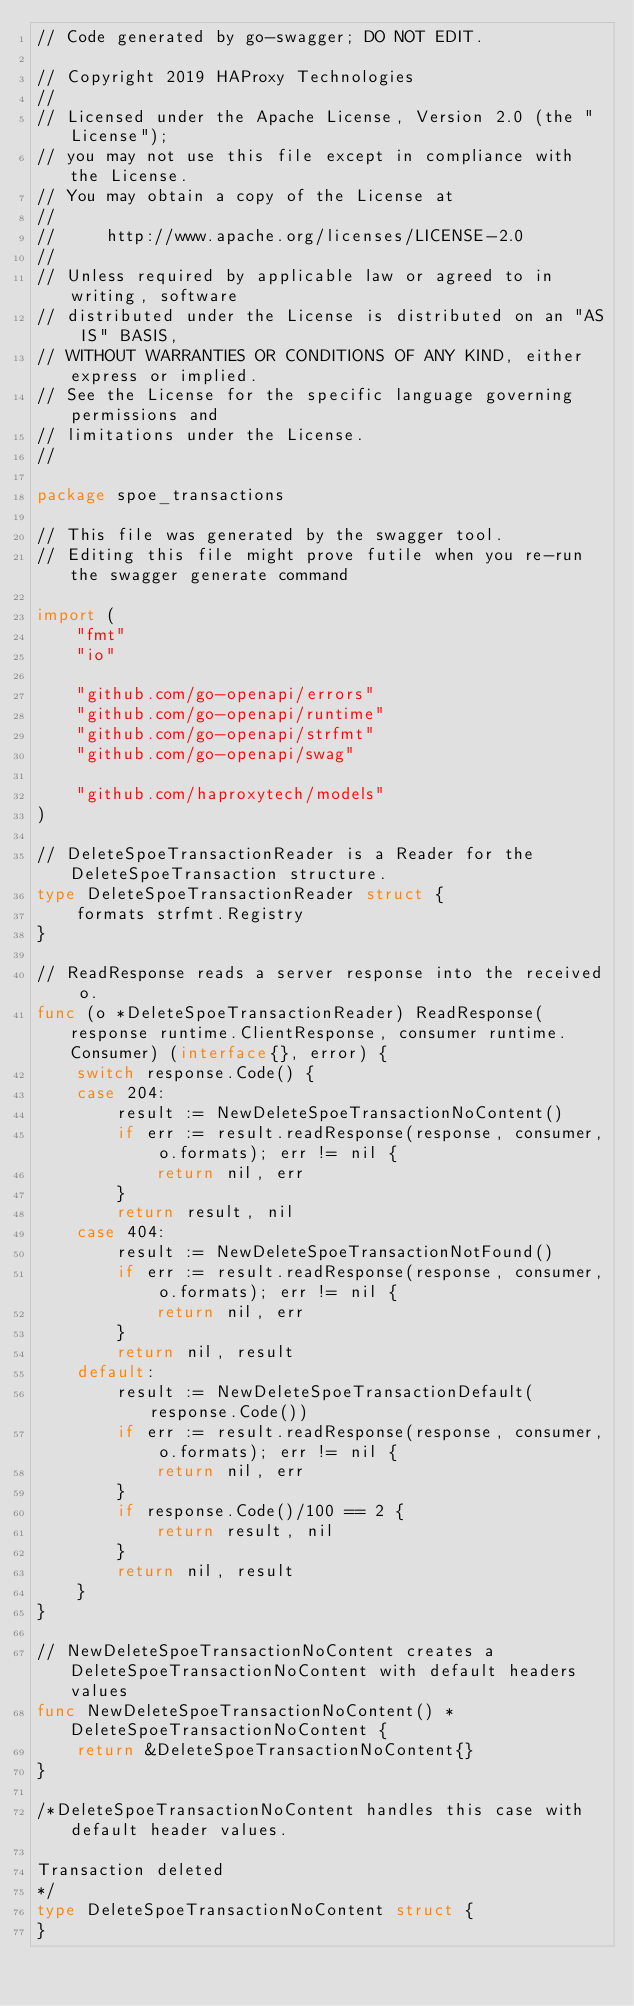Convert code to text. <code><loc_0><loc_0><loc_500><loc_500><_Go_>// Code generated by go-swagger; DO NOT EDIT.

// Copyright 2019 HAProxy Technologies
//
// Licensed under the Apache License, Version 2.0 (the "License");
// you may not use this file except in compliance with the License.
// You may obtain a copy of the License at
//
//     http://www.apache.org/licenses/LICENSE-2.0
//
// Unless required by applicable law or agreed to in writing, software
// distributed under the License is distributed on an "AS IS" BASIS,
// WITHOUT WARRANTIES OR CONDITIONS OF ANY KIND, either express or implied.
// See the License for the specific language governing permissions and
// limitations under the License.
//

package spoe_transactions

// This file was generated by the swagger tool.
// Editing this file might prove futile when you re-run the swagger generate command

import (
	"fmt"
	"io"

	"github.com/go-openapi/errors"
	"github.com/go-openapi/runtime"
	"github.com/go-openapi/strfmt"
	"github.com/go-openapi/swag"

	"github.com/haproxytech/models"
)

// DeleteSpoeTransactionReader is a Reader for the DeleteSpoeTransaction structure.
type DeleteSpoeTransactionReader struct {
	formats strfmt.Registry
}

// ReadResponse reads a server response into the received o.
func (o *DeleteSpoeTransactionReader) ReadResponse(response runtime.ClientResponse, consumer runtime.Consumer) (interface{}, error) {
	switch response.Code() {
	case 204:
		result := NewDeleteSpoeTransactionNoContent()
		if err := result.readResponse(response, consumer, o.formats); err != nil {
			return nil, err
		}
		return result, nil
	case 404:
		result := NewDeleteSpoeTransactionNotFound()
		if err := result.readResponse(response, consumer, o.formats); err != nil {
			return nil, err
		}
		return nil, result
	default:
		result := NewDeleteSpoeTransactionDefault(response.Code())
		if err := result.readResponse(response, consumer, o.formats); err != nil {
			return nil, err
		}
		if response.Code()/100 == 2 {
			return result, nil
		}
		return nil, result
	}
}

// NewDeleteSpoeTransactionNoContent creates a DeleteSpoeTransactionNoContent with default headers values
func NewDeleteSpoeTransactionNoContent() *DeleteSpoeTransactionNoContent {
	return &DeleteSpoeTransactionNoContent{}
}

/*DeleteSpoeTransactionNoContent handles this case with default header values.

Transaction deleted
*/
type DeleteSpoeTransactionNoContent struct {
}
</code> 